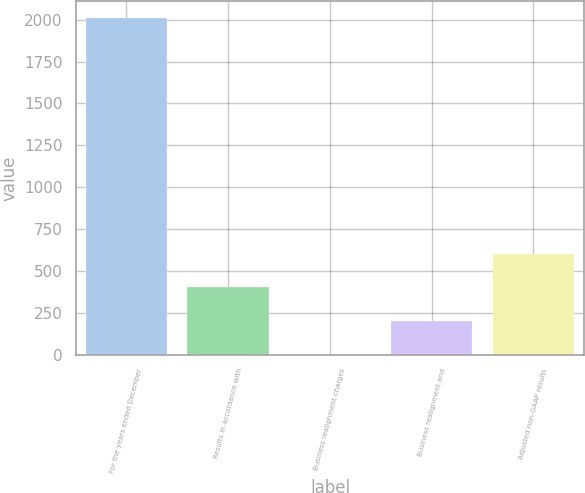Convert chart. <chart><loc_0><loc_0><loc_500><loc_500><bar_chart><fcel>For the years ended December<fcel>Results in accordance with<fcel>Business realignment charges<fcel>Business realignment and<fcel>Adjusted non-GAAP results<nl><fcel>2009<fcel>401.83<fcel>0.03<fcel>200.93<fcel>602.73<nl></chart> 